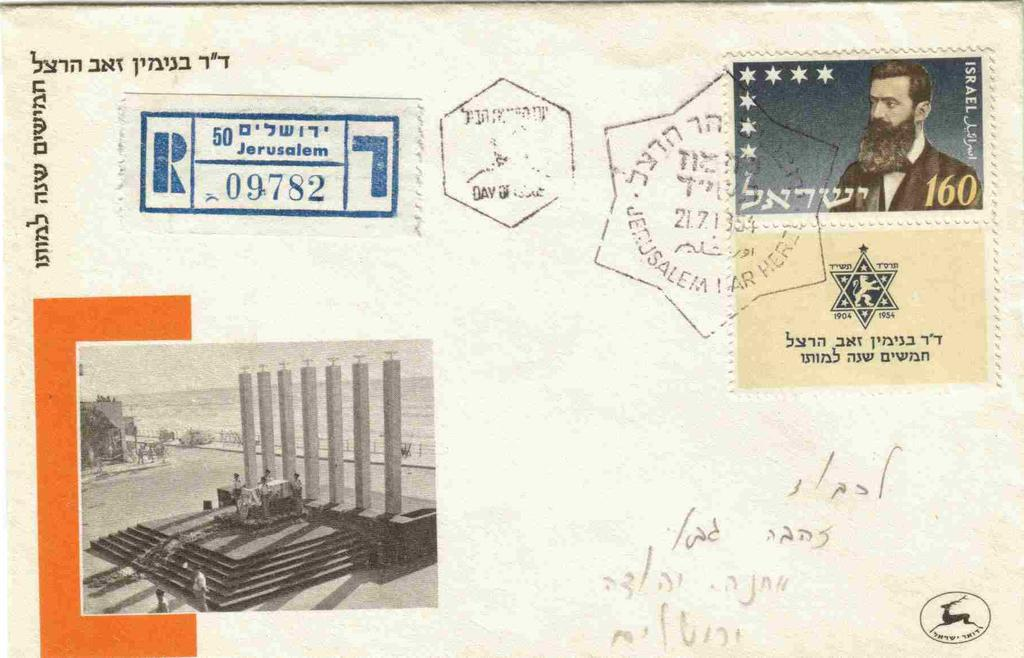Provide a one-sentence caption for the provided image. A postcard which accrding to the postmark has been sent from Israel. 